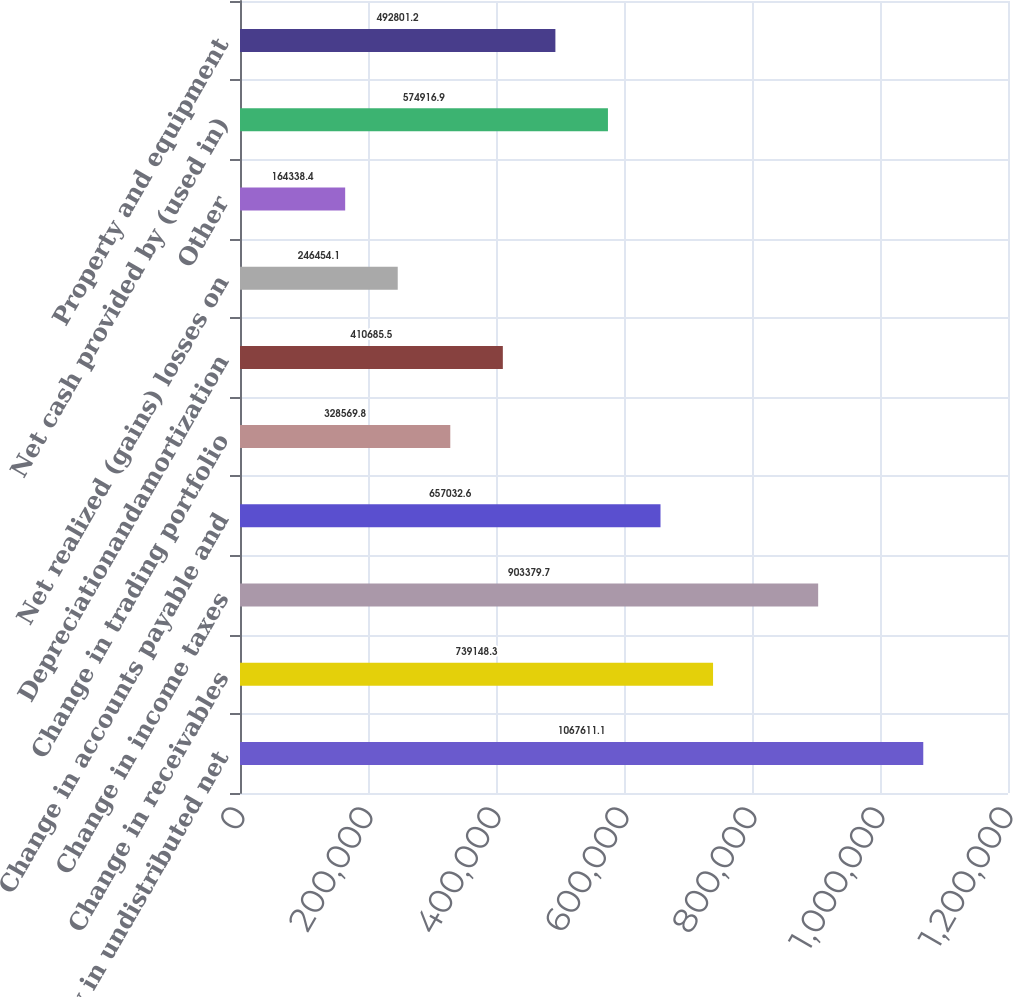Convert chart to OTSL. <chart><loc_0><loc_0><loc_500><loc_500><bar_chart><fcel>Equity in undistributed net<fcel>Change in receivables<fcel>Change in income taxes<fcel>Change in accounts payable and<fcel>Change in trading portfolio<fcel>Depreciationandamortization<fcel>Net realized (gains) losses on<fcel>Other<fcel>Net cash provided by (used in)<fcel>Property and equipment<nl><fcel>1.06761e+06<fcel>739148<fcel>903380<fcel>657033<fcel>328570<fcel>410686<fcel>246454<fcel>164338<fcel>574917<fcel>492801<nl></chart> 